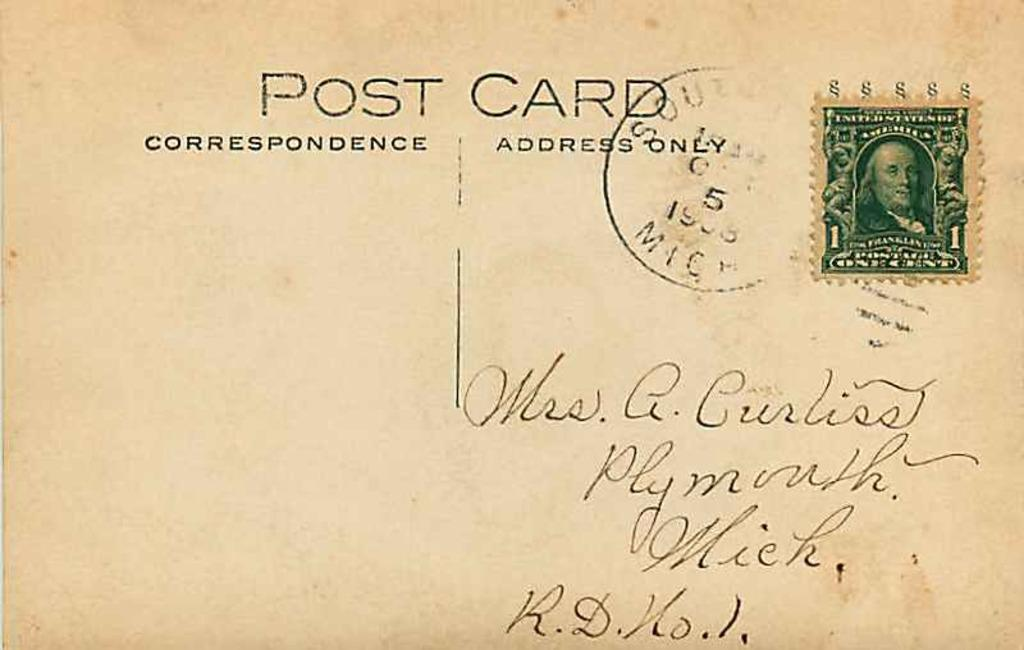<image>
Create a compact narrative representing the image presented. Post Card Correspondence and Address that says Mrs. A. Curliss Plymouth Mich, R.D. No. 1. 